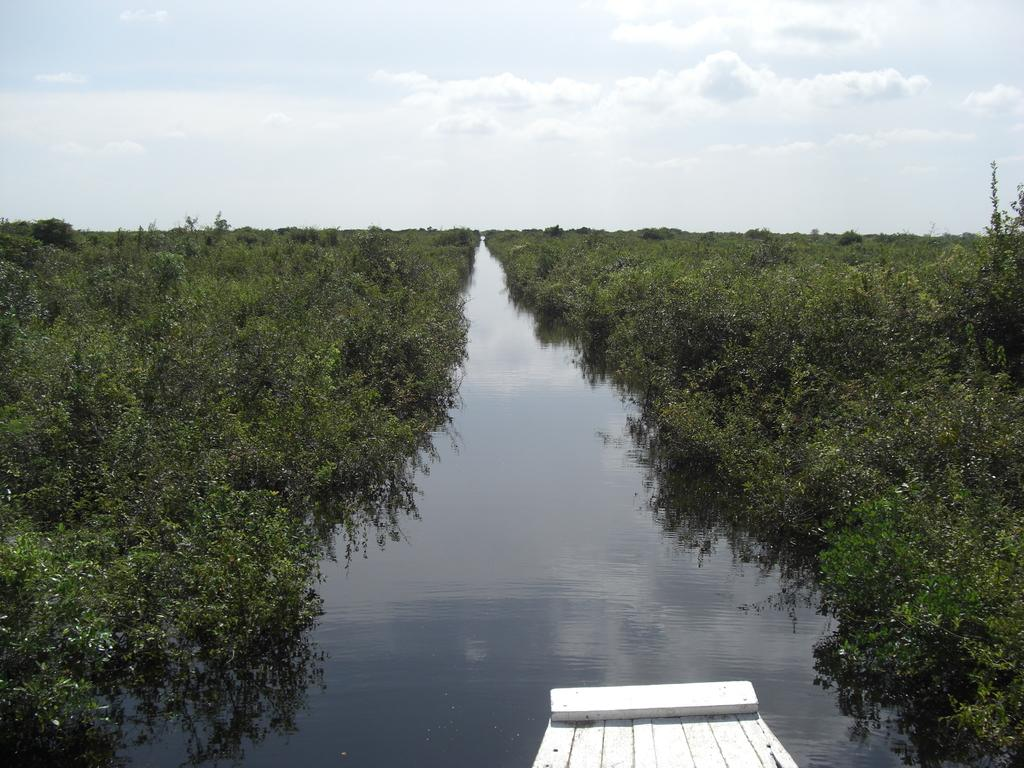What is visible in the image? Water is visible in the image. What can be seen in the background of the image? There are trees in the background of the image. What is the color of the trees? The trees are green in color. What is the color of the sky in the image? The sky is white in color. What is the name of the queen who is present in the image? There is no queen present in the image. 